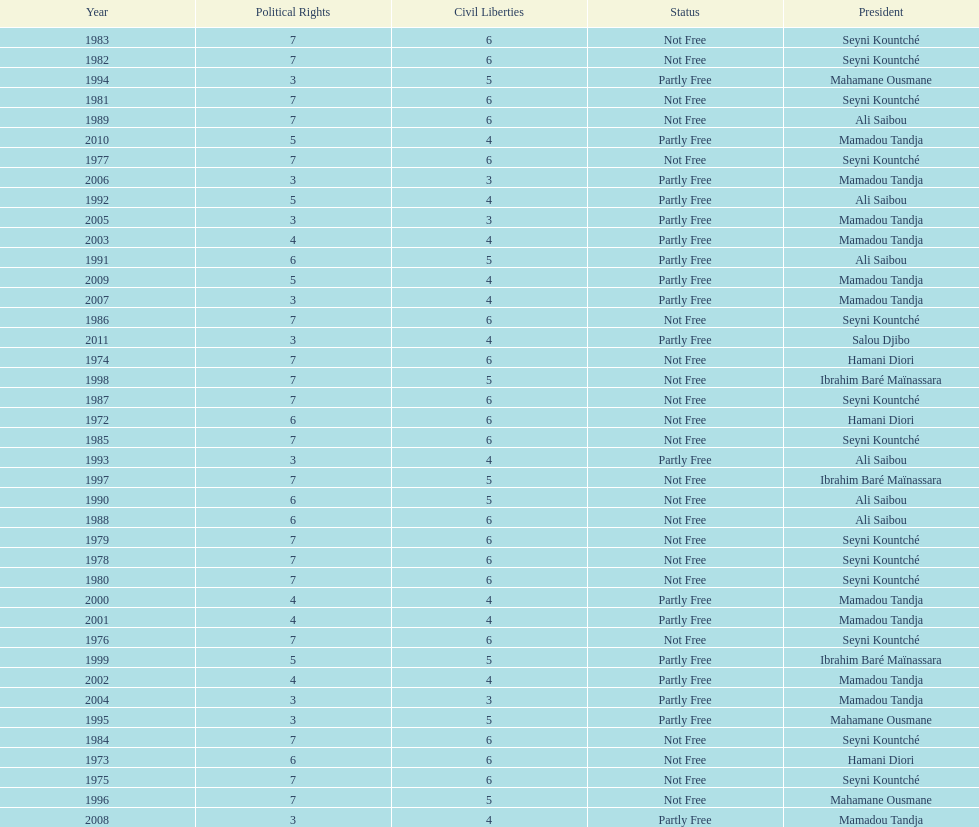How many years was ali saibou president? 6. 